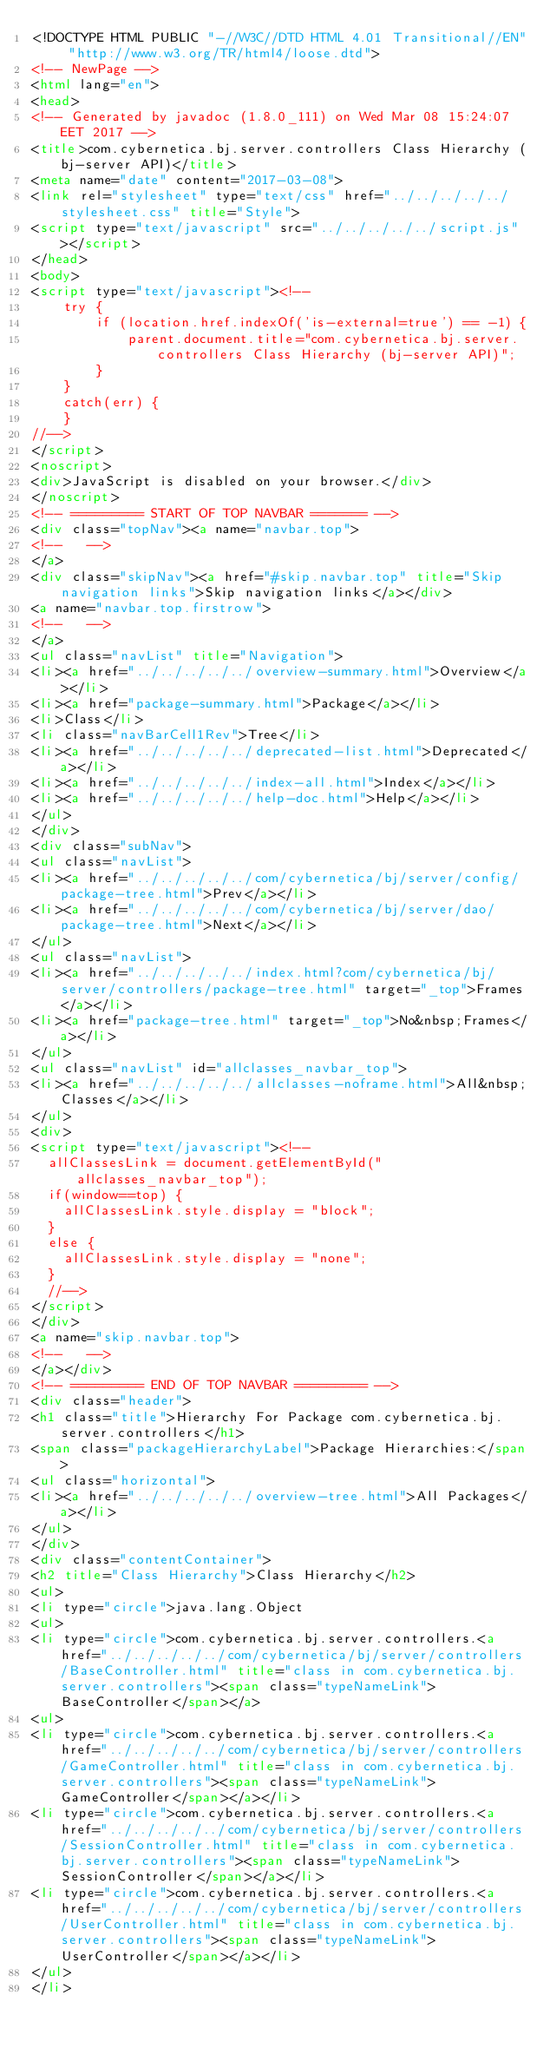<code> <loc_0><loc_0><loc_500><loc_500><_HTML_><!DOCTYPE HTML PUBLIC "-//W3C//DTD HTML 4.01 Transitional//EN" "http://www.w3.org/TR/html4/loose.dtd">
<!-- NewPage -->
<html lang="en">
<head>
<!-- Generated by javadoc (1.8.0_111) on Wed Mar 08 15:24:07 EET 2017 -->
<title>com.cybernetica.bj.server.controllers Class Hierarchy (bj-server API)</title>
<meta name="date" content="2017-03-08">
<link rel="stylesheet" type="text/css" href="../../../../../stylesheet.css" title="Style">
<script type="text/javascript" src="../../../../../script.js"></script>
</head>
<body>
<script type="text/javascript"><!--
    try {
        if (location.href.indexOf('is-external=true') == -1) {
            parent.document.title="com.cybernetica.bj.server.controllers Class Hierarchy (bj-server API)";
        }
    }
    catch(err) {
    }
//-->
</script>
<noscript>
<div>JavaScript is disabled on your browser.</div>
</noscript>
<!-- ========= START OF TOP NAVBAR ======= -->
<div class="topNav"><a name="navbar.top">
<!--   -->
</a>
<div class="skipNav"><a href="#skip.navbar.top" title="Skip navigation links">Skip navigation links</a></div>
<a name="navbar.top.firstrow">
<!--   -->
</a>
<ul class="navList" title="Navigation">
<li><a href="../../../../../overview-summary.html">Overview</a></li>
<li><a href="package-summary.html">Package</a></li>
<li>Class</li>
<li class="navBarCell1Rev">Tree</li>
<li><a href="../../../../../deprecated-list.html">Deprecated</a></li>
<li><a href="../../../../../index-all.html">Index</a></li>
<li><a href="../../../../../help-doc.html">Help</a></li>
</ul>
</div>
<div class="subNav">
<ul class="navList">
<li><a href="../../../../../com/cybernetica/bj/server/config/package-tree.html">Prev</a></li>
<li><a href="../../../../../com/cybernetica/bj/server/dao/package-tree.html">Next</a></li>
</ul>
<ul class="navList">
<li><a href="../../../../../index.html?com/cybernetica/bj/server/controllers/package-tree.html" target="_top">Frames</a></li>
<li><a href="package-tree.html" target="_top">No&nbsp;Frames</a></li>
</ul>
<ul class="navList" id="allclasses_navbar_top">
<li><a href="../../../../../allclasses-noframe.html">All&nbsp;Classes</a></li>
</ul>
<div>
<script type="text/javascript"><!--
  allClassesLink = document.getElementById("allclasses_navbar_top");
  if(window==top) {
    allClassesLink.style.display = "block";
  }
  else {
    allClassesLink.style.display = "none";
  }
  //-->
</script>
</div>
<a name="skip.navbar.top">
<!--   -->
</a></div>
<!-- ========= END OF TOP NAVBAR ========= -->
<div class="header">
<h1 class="title">Hierarchy For Package com.cybernetica.bj.server.controllers</h1>
<span class="packageHierarchyLabel">Package Hierarchies:</span>
<ul class="horizontal">
<li><a href="../../../../../overview-tree.html">All Packages</a></li>
</ul>
</div>
<div class="contentContainer">
<h2 title="Class Hierarchy">Class Hierarchy</h2>
<ul>
<li type="circle">java.lang.Object
<ul>
<li type="circle">com.cybernetica.bj.server.controllers.<a href="../../../../../com/cybernetica/bj/server/controllers/BaseController.html" title="class in com.cybernetica.bj.server.controllers"><span class="typeNameLink">BaseController</span></a>
<ul>
<li type="circle">com.cybernetica.bj.server.controllers.<a href="../../../../../com/cybernetica/bj/server/controllers/GameController.html" title="class in com.cybernetica.bj.server.controllers"><span class="typeNameLink">GameController</span></a></li>
<li type="circle">com.cybernetica.bj.server.controllers.<a href="../../../../../com/cybernetica/bj/server/controllers/SessionController.html" title="class in com.cybernetica.bj.server.controllers"><span class="typeNameLink">SessionController</span></a></li>
<li type="circle">com.cybernetica.bj.server.controllers.<a href="../../../../../com/cybernetica/bj/server/controllers/UserController.html" title="class in com.cybernetica.bj.server.controllers"><span class="typeNameLink">UserController</span></a></li>
</ul>
</li></code> 